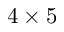Convert formula to latex. <formula><loc_0><loc_0><loc_500><loc_500>4 \times 5</formula> 